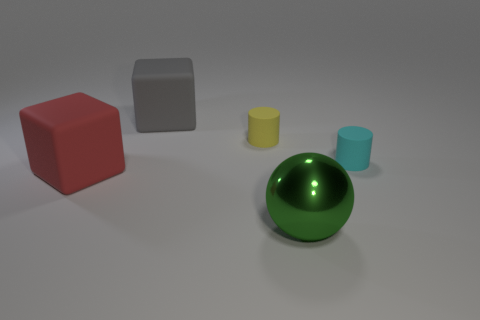Add 1 big green spheres. How many objects exist? 6 Subtract all cubes. How many objects are left? 3 Add 1 big objects. How many big objects exist? 4 Subtract 1 yellow cylinders. How many objects are left? 4 Subtract all large gray blocks. Subtract all gray blocks. How many objects are left? 3 Add 2 big gray rubber objects. How many big gray rubber objects are left? 3 